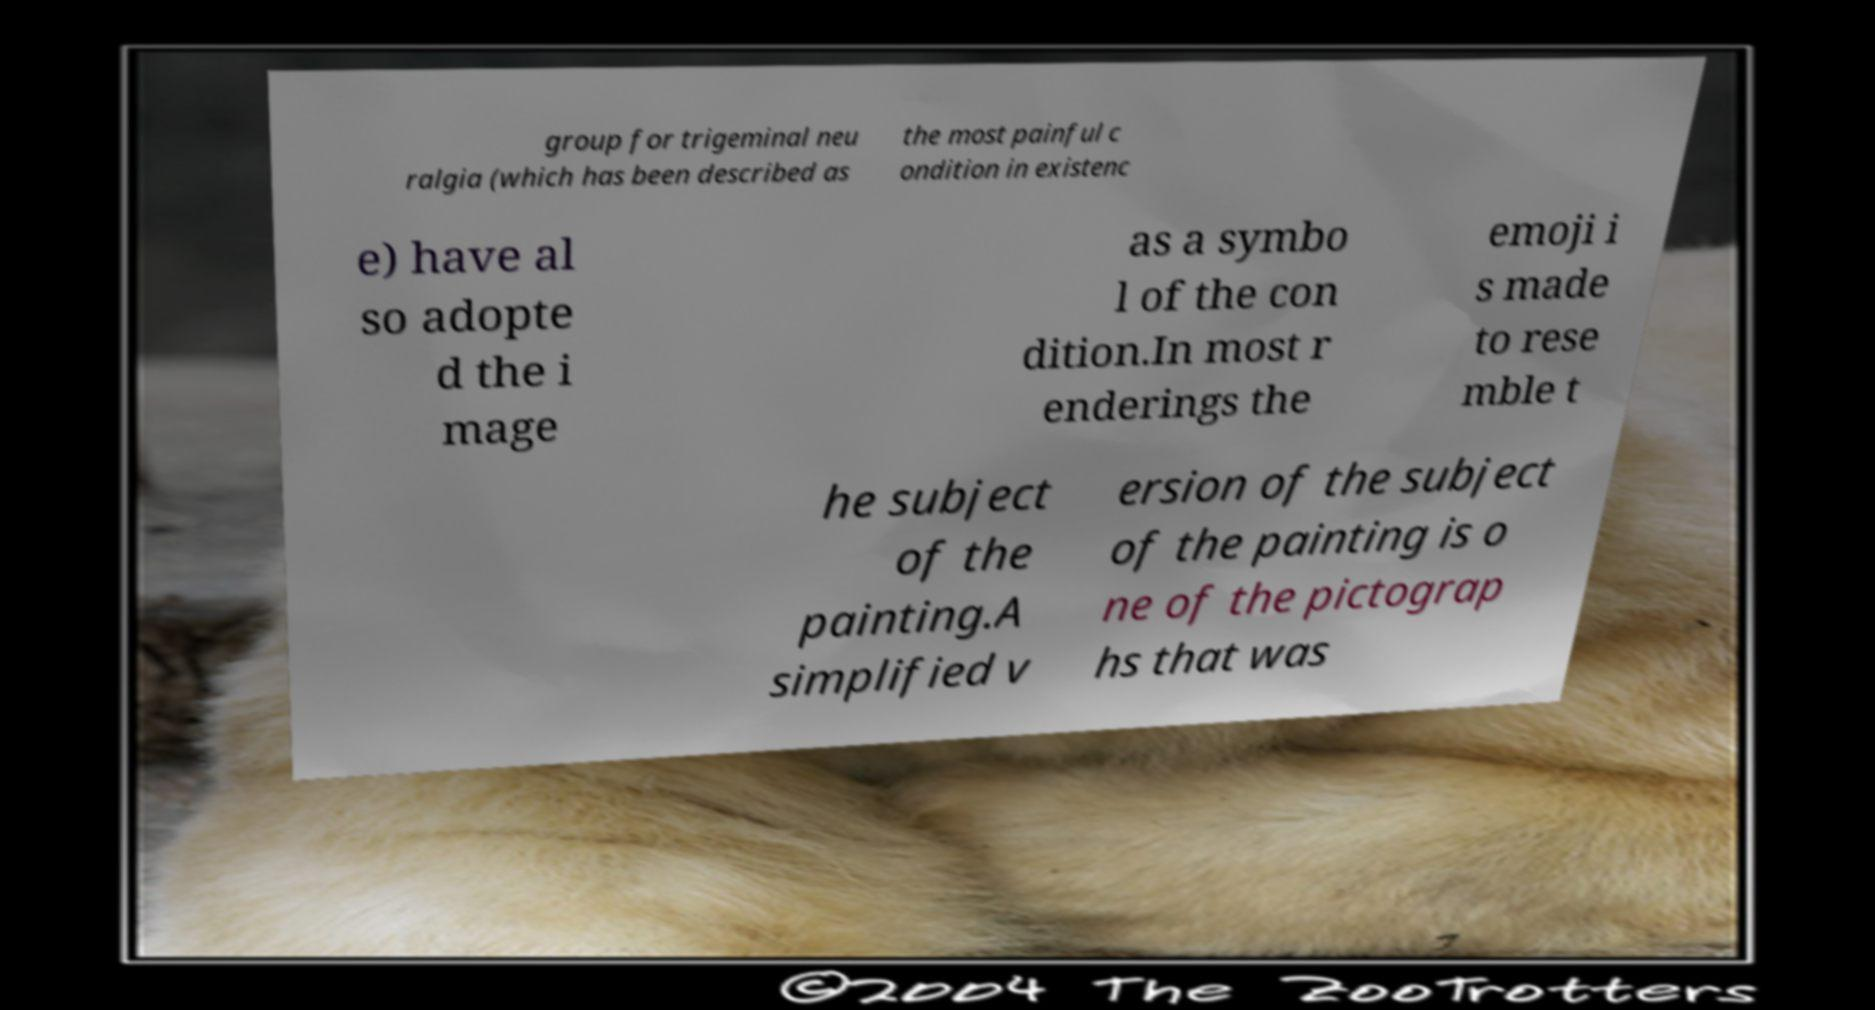For documentation purposes, I need the text within this image transcribed. Could you provide that? group for trigeminal neu ralgia (which has been described as the most painful c ondition in existenc e) have al so adopte d the i mage as a symbo l of the con dition.In most r enderings the emoji i s made to rese mble t he subject of the painting.A simplified v ersion of the subject of the painting is o ne of the pictograp hs that was 